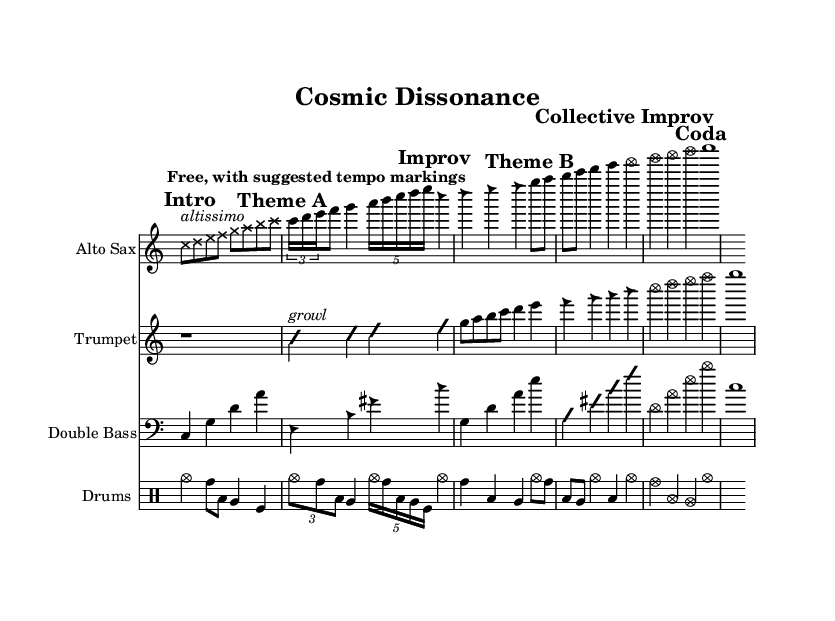What is the tempo marking in this music? The music states "Free, with suggested tempo markings" indicating a flexible approach to tempo, typical in avant-garde jazz.
Answer: Free, with suggested tempo markings What is the time signature used in this piece? The score does not have a visible time signature indicated in the staves, as it contains free improvisation sections typical in avant-garde jazz.
Answer: None Which instrument plays the collective improvisation section? The sections labeled "Collective Improv" appear in both the trumpet and double bass staves, indicating that multiple instruments are involved in that section.
Answer: Trumpet, Double Bass How many measures are there in Theme A? Theme A consists of a total of 5 measures combined from the alto sax and trumpet parts. This can be counted visually by examining the respective sections.
Answer: 5 What is the predominant characteristic of the improvisation sections? The improvisation sections feature a mix of both structured and freely interpreted notes, which is a hallmark of avant-garde free jazz style indicating individual expression within the collective.
Answer: Free interpretation What kind of notes are used for the alto sax in the "Intro" section? The alto sax in the "Intro" section has cross-styled note heads which often signify a specific technique or style, differing from the standard note heads, indicating an avant-garde approach.
Answer: Cross-styled note heads What is the style of note heads used in the Theme B for trumpet? The trumpet uses triangle-styled note heads in Theme B, which often indicates a specific articulation or playing technique in jazz, particularly within improvisation contexts.
Answer: Triangle-styled note heads 